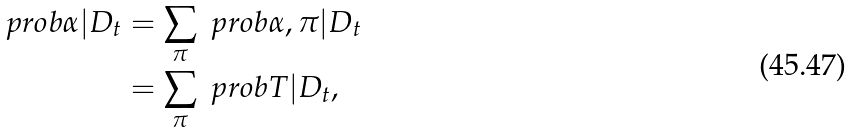<formula> <loc_0><loc_0><loc_500><loc_500>\ p r o b { \alpha | D _ { t } } & = \sum _ { \pi } \ p r o b { \alpha , \pi | D _ { t } } \\ & = \sum _ { \pi } \ p r o b { T | D _ { t } } ,</formula> 